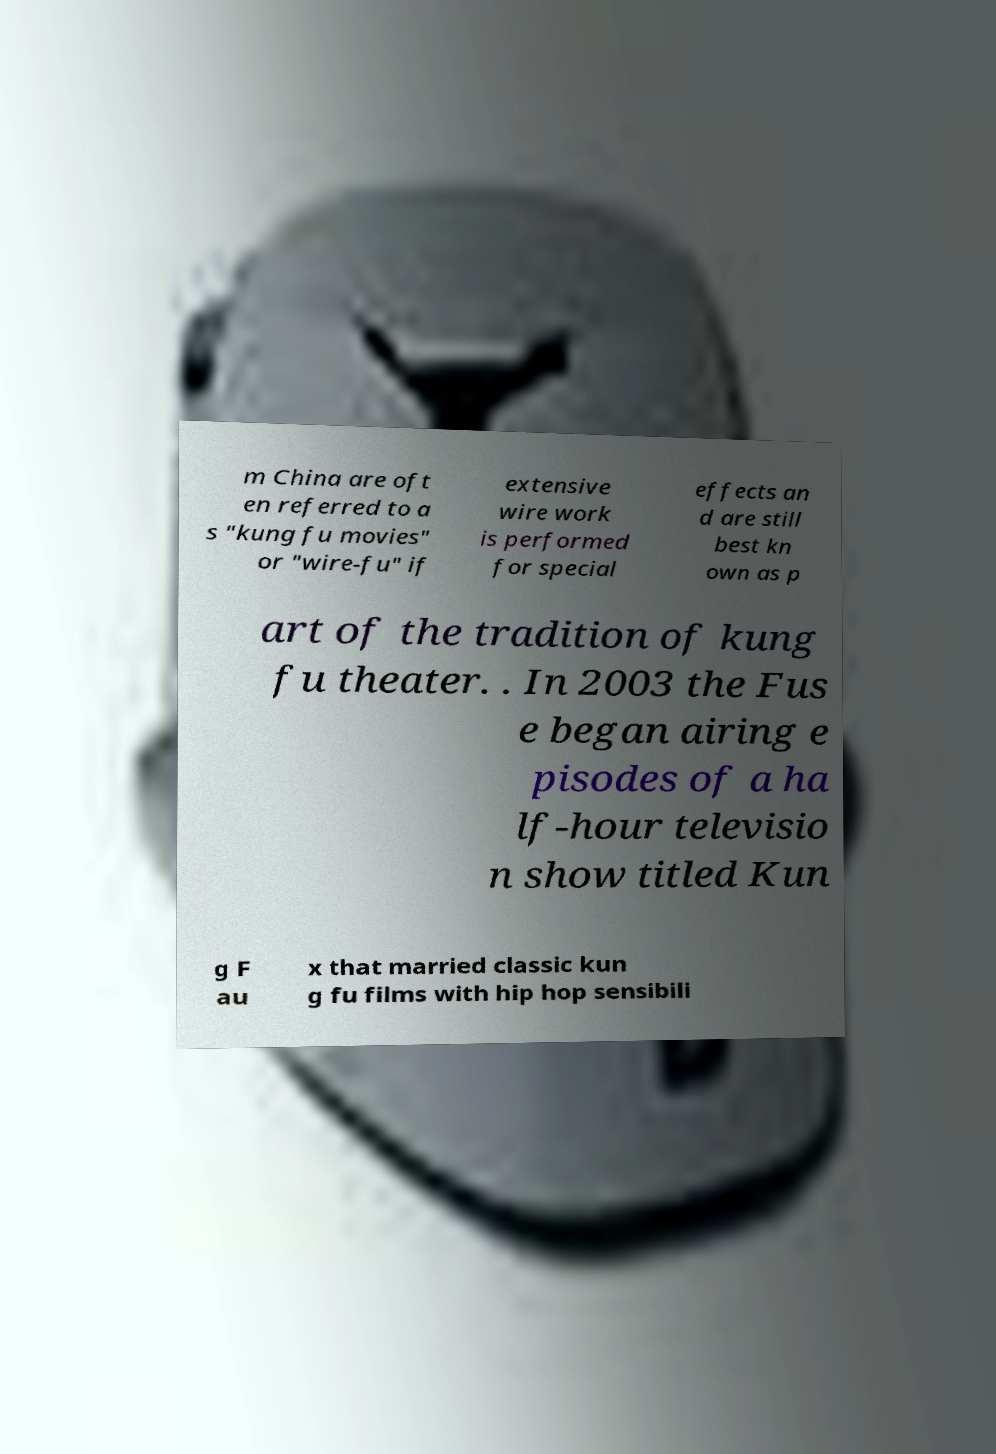Can you accurately transcribe the text from the provided image for me? m China are oft en referred to a s "kung fu movies" or "wire-fu" if extensive wire work is performed for special effects an d are still best kn own as p art of the tradition of kung fu theater. . In 2003 the Fus e began airing e pisodes of a ha lf-hour televisio n show titled Kun g F au x that married classic kun g fu films with hip hop sensibili 